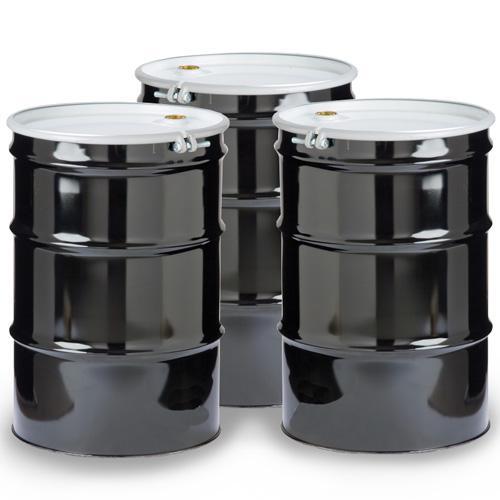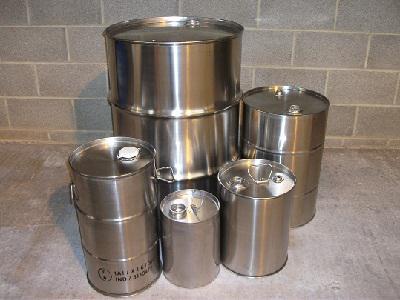The first image is the image on the left, the second image is the image on the right. For the images displayed, is the sentence "All barrels are gray steel and some barrels have open tops." factually correct? Answer yes or no. No. The first image is the image on the left, the second image is the image on the right. For the images shown, is this caption "There are more silver barrels in the image on the left than on the right." true? Answer yes or no. No. 